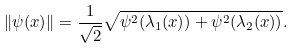Convert formula to latex. <formula><loc_0><loc_0><loc_500><loc_500>\| \psi ( x ) \| = \frac { 1 } { \sqrt { 2 } } \sqrt { \psi ^ { 2 } ( \lambda _ { 1 } ( x ) ) + \psi ^ { 2 } ( \lambda _ { 2 } ( x ) ) } .</formula> 